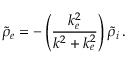<formula> <loc_0><loc_0><loc_500><loc_500>\widetilde { \rho } _ { e } = - \left ( \frac { k _ { e } ^ { 2 } } { k ^ { 2 } + k _ { e } ^ { 2 } } \right ) \widetilde { \rho } _ { i } \, .</formula> 